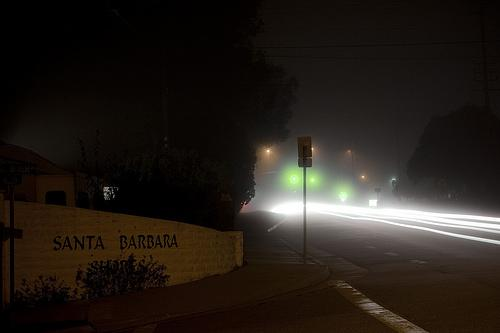Question: what is outlined by the road?
Choices:
A. Fence.
B. A sign.
C. Compound.
D. City block.
Answer with the letter. Answer: B Question: where is this picture taken?
Choices:
A. A sidewalk.
B. A road.
C. A trail.
D. A parking lot.
Answer with the letter. Answer: B Question: where does the road lead?
Choices:
A. San Francisco.
B. San Diego.
C. Santa Barbara.
D. Palo Alto.
Answer with the letter. Answer: C Question: when was this picture taken?
Choices:
A. Evening.
B. Midnight.
C. Dawn.
D. Night time.
Answer with the letter. Answer: D Question: where are the lights coming from?
Choices:
A. Streetlight.
B. Cars.
C. Headlights.
D. Flashlights.
Answer with the letter. Answer: B 